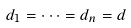<formula> <loc_0><loc_0><loc_500><loc_500>d _ { 1 } = \cdots = d _ { n } = d</formula> 